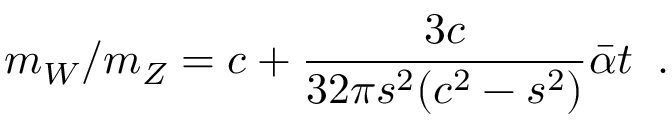<formula> <loc_0><loc_0><loc_500><loc_500>m _ { W } / m _ { Z } = c + \frac { 3 c } { 3 2 \pi s ^ { 2 } ( c ^ { 2 } - s ^ { 2 } ) } \bar { \alpha } t \, .</formula> 